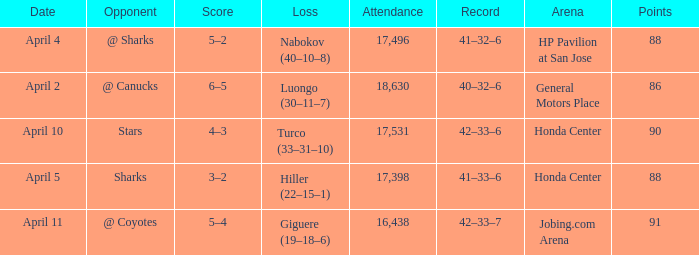Which Loss has a Record of 41–32–6? Nabokov (40–10–8). 